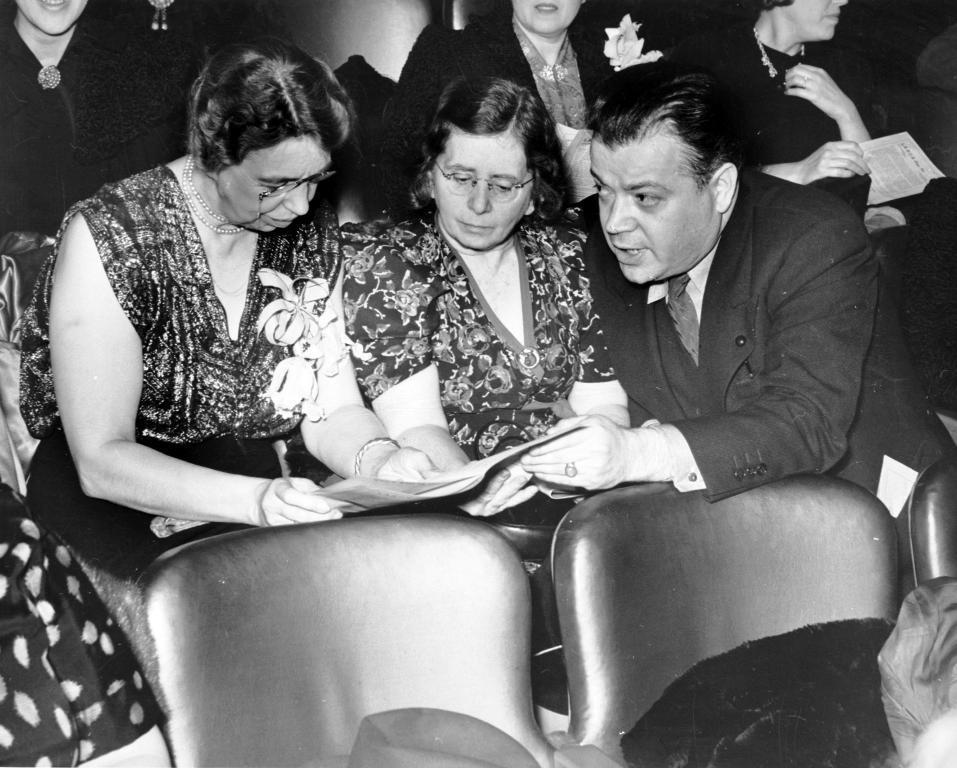Could you give a brief overview of what you see in this image? This is black and white image, in this image people are sitting on chairs. 